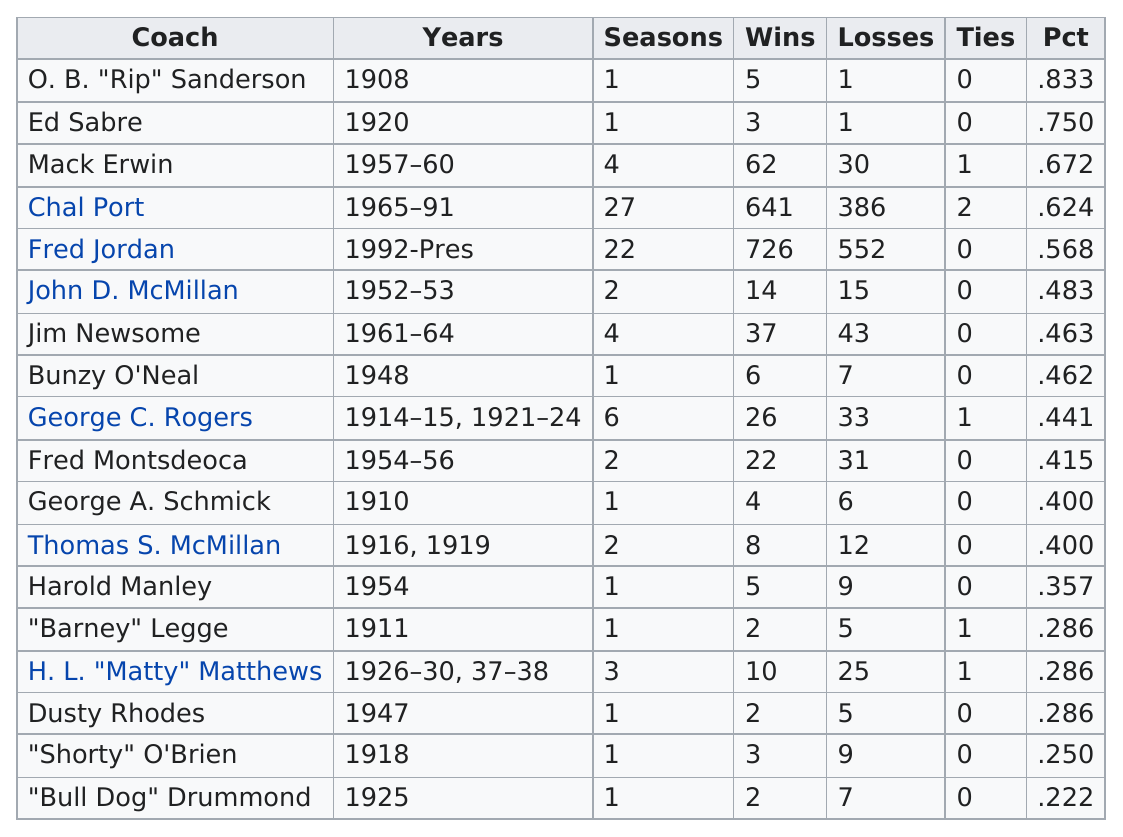Identify some key points in this picture. In 1948, the percentage of Native American students who graduated from high school was 46.2%. Ed Sabre is the last coach to have only one loss, making him an exceptional coach in the world of sports. In the period of time when Fred Jordan was the head coach, the win percentage was 0.056 higher than when Chal Port was the head coach. H.L. Matthews was actively coaching for five years. George C. Rogers coached a total of 6 seasons. 